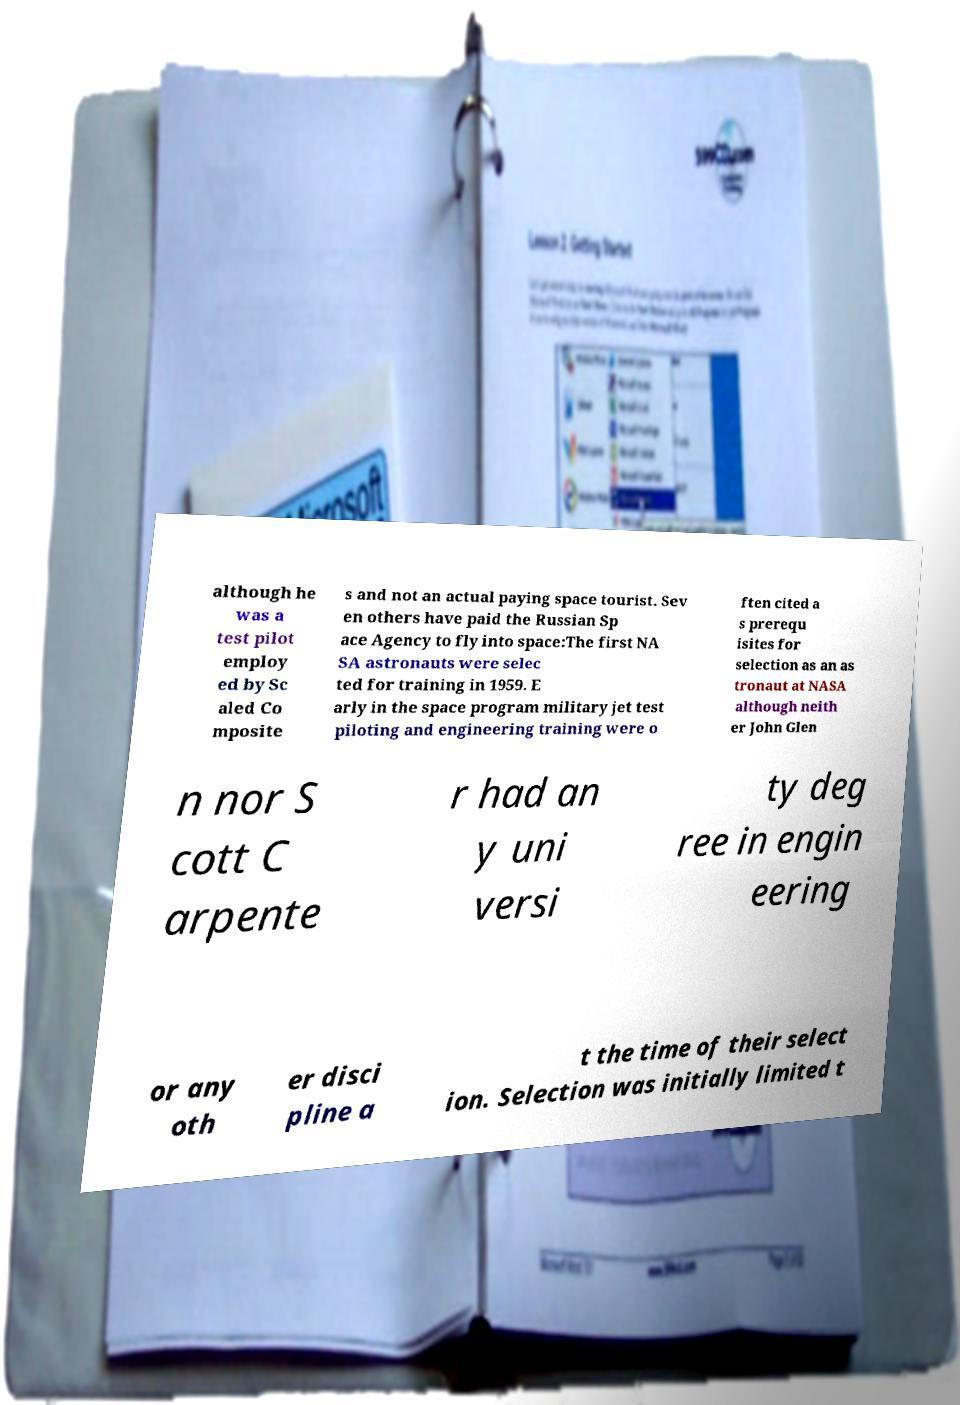Can you read and provide the text displayed in the image?This photo seems to have some interesting text. Can you extract and type it out for me? although he was a test pilot employ ed by Sc aled Co mposite s and not an actual paying space tourist. Sev en others have paid the Russian Sp ace Agency to fly into space:The first NA SA astronauts were selec ted for training in 1959. E arly in the space program military jet test piloting and engineering training were o ften cited a s prerequ isites for selection as an as tronaut at NASA although neith er John Glen n nor S cott C arpente r had an y uni versi ty deg ree in engin eering or any oth er disci pline a t the time of their select ion. Selection was initially limited t 